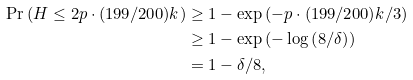<formula> <loc_0><loc_0><loc_500><loc_500>\Pr \left ( H \leq 2 p \cdot ( 1 9 9 / 2 0 0 ) k \right ) & \geq 1 - \exp \left ( - p \cdot ( 1 9 9 / 2 0 0 ) k / 3 \right ) \\ & \geq 1 - \exp \left ( - \log \left ( 8 / \delta \right ) \right ) \\ & = 1 - \delta / 8 ,</formula> 